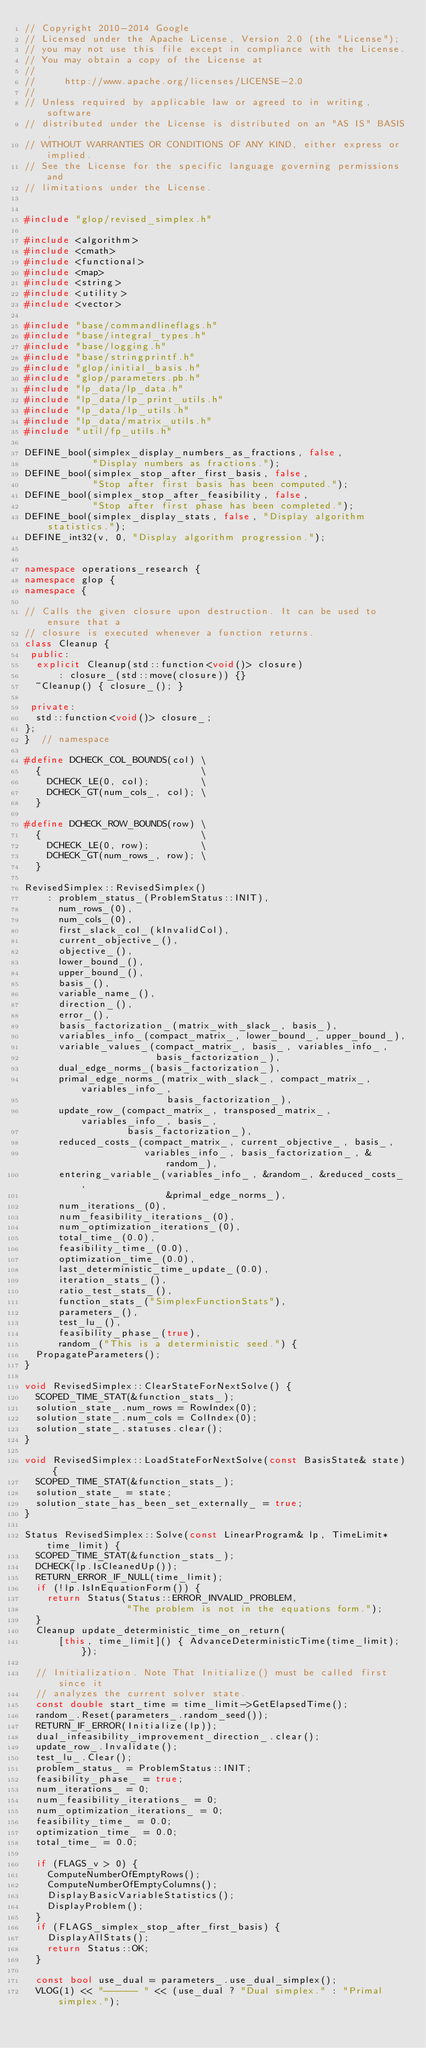Convert code to text. <code><loc_0><loc_0><loc_500><loc_500><_C++_>// Copyright 2010-2014 Google
// Licensed under the Apache License, Version 2.0 (the "License");
// you may not use this file except in compliance with the License.
// You may obtain a copy of the License at
//
//     http://www.apache.org/licenses/LICENSE-2.0
//
// Unless required by applicable law or agreed to in writing, software
// distributed under the License is distributed on an "AS IS" BASIS,
// WITHOUT WARRANTIES OR CONDITIONS OF ANY KIND, either express or implied.
// See the License for the specific language governing permissions and
// limitations under the License.


#include "glop/revised_simplex.h"

#include <algorithm>
#include <cmath>
#include <functional>
#include <map>
#include <string>
#include <utility>
#include <vector>

#include "base/commandlineflags.h"
#include "base/integral_types.h"
#include "base/logging.h"
#include "base/stringprintf.h"
#include "glop/initial_basis.h"
#include "glop/parameters.pb.h"
#include "lp_data/lp_data.h"
#include "lp_data/lp_print_utils.h"
#include "lp_data/lp_utils.h"
#include "lp_data/matrix_utils.h"
#include "util/fp_utils.h"

DEFINE_bool(simplex_display_numbers_as_fractions, false,
            "Display numbers as fractions.");
DEFINE_bool(simplex_stop_after_first_basis, false,
            "Stop after first basis has been computed.");
DEFINE_bool(simplex_stop_after_feasibility, false,
            "Stop after first phase has been completed.");
DEFINE_bool(simplex_display_stats, false, "Display algorithm statistics.");
DEFINE_int32(v, 0, "Display algorithm progression.");


namespace operations_research {
namespace glop {
namespace {

// Calls the given closure upon destruction. It can be used to ensure that a
// closure is executed whenever a function returns.
class Cleanup {
 public:
  explicit Cleanup(std::function<void()> closure)
      : closure_(std::move(closure)) {}
  ~Cleanup() { closure_(); }

 private:
  std::function<void()> closure_;
};
}  // namespace

#define DCHECK_COL_BOUNDS(col) \
  {                            \
    DCHECK_LE(0, col);         \
    DCHECK_GT(num_cols_, col); \
  }

#define DCHECK_ROW_BOUNDS(row) \
  {                            \
    DCHECK_LE(0, row);         \
    DCHECK_GT(num_rows_, row); \
  }

RevisedSimplex::RevisedSimplex()
    : problem_status_(ProblemStatus::INIT),
      num_rows_(0),
      num_cols_(0),
      first_slack_col_(kInvalidCol),
      current_objective_(),
      objective_(),
      lower_bound_(),
      upper_bound_(),
      basis_(),
      variable_name_(),
      direction_(),
      error_(),
      basis_factorization_(matrix_with_slack_, basis_),
      variables_info_(compact_matrix_, lower_bound_, upper_bound_),
      variable_values_(compact_matrix_, basis_, variables_info_,
                       basis_factorization_),
      dual_edge_norms_(basis_factorization_),
      primal_edge_norms_(matrix_with_slack_, compact_matrix_, variables_info_,
                         basis_factorization_),
      update_row_(compact_matrix_, transposed_matrix_, variables_info_, basis_,
                  basis_factorization_),
      reduced_costs_(compact_matrix_, current_objective_, basis_,
                     variables_info_, basis_factorization_, &random_),
      entering_variable_(variables_info_, &random_, &reduced_costs_,
                         &primal_edge_norms_),
      num_iterations_(0),
      num_feasibility_iterations_(0),
      num_optimization_iterations_(0),
      total_time_(0.0),
      feasibility_time_(0.0),
      optimization_time_(0.0),
      last_deterministic_time_update_(0.0),
      iteration_stats_(),
      ratio_test_stats_(),
      function_stats_("SimplexFunctionStats"),
      parameters_(),
      test_lu_(),
      feasibility_phase_(true),
      random_("This is a deterministic seed.") {
  PropagateParameters();
}

void RevisedSimplex::ClearStateForNextSolve() {
  SCOPED_TIME_STAT(&function_stats_);
  solution_state_.num_rows = RowIndex(0);
  solution_state_.num_cols = ColIndex(0);
  solution_state_.statuses.clear();
}

void RevisedSimplex::LoadStateForNextSolve(const BasisState& state) {
  SCOPED_TIME_STAT(&function_stats_);
  solution_state_ = state;
  solution_state_has_been_set_externally_ = true;
}

Status RevisedSimplex::Solve(const LinearProgram& lp, TimeLimit* time_limit) {
  SCOPED_TIME_STAT(&function_stats_);
  DCHECK(lp.IsCleanedUp());
  RETURN_ERROR_IF_NULL(time_limit);
  if (!lp.IsInEquationForm()) {
    return Status(Status::ERROR_INVALID_PROBLEM,
                  "The problem is not in the equations form.");
  }
  Cleanup update_deterministic_time_on_return(
      [this, time_limit]() { AdvanceDeterministicTime(time_limit); });

  // Initialization. Note That Initialize() must be called first since it
  // analyzes the current solver state.
  const double start_time = time_limit->GetElapsedTime();
  random_.Reset(parameters_.random_seed());
  RETURN_IF_ERROR(Initialize(lp));
  dual_infeasibility_improvement_direction_.clear();
  update_row_.Invalidate();
  test_lu_.Clear();
  problem_status_ = ProblemStatus::INIT;
  feasibility_phase_ = true;
  num_iterations_ = 0;
  num_feasibility_iterations_ = 0;
  num_optimization_iterations_ = 0;
  feasibility_time_ = 0.0;
  optimization_time_ = 0.0;
  total_time_ = 0.0;

  if (FLAGS_v > 0) {
    ComputeNumberOfEmptyRows();
    ComputeNumberOfEmptyColumns();
    DisplayBasicVariableStatistics();
    DisplayProblem();
  }
  if (FLAGS_simplex_stop_after_first_basis) {
    DisplayAllStats();
    return Status::OK;
  }

  const bool use_dual = parameters_.use_dual_simplex();
  VLOG(1) << "------ " << (use_dual ? "Dual simplex." : "Primal simplex.");</code> 